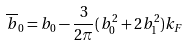Convert formula to latex. <formula><loc_0><loc_0><loc_500><loc_500>\overline { b } _ { 0 } = b _ { 0 } - \frac { 3 } { 2 \pi } ( b _ { 0 } ^ { 2 } + 2 b _ { 1 } ^ { 2 } ) k _ { F }</formula> 